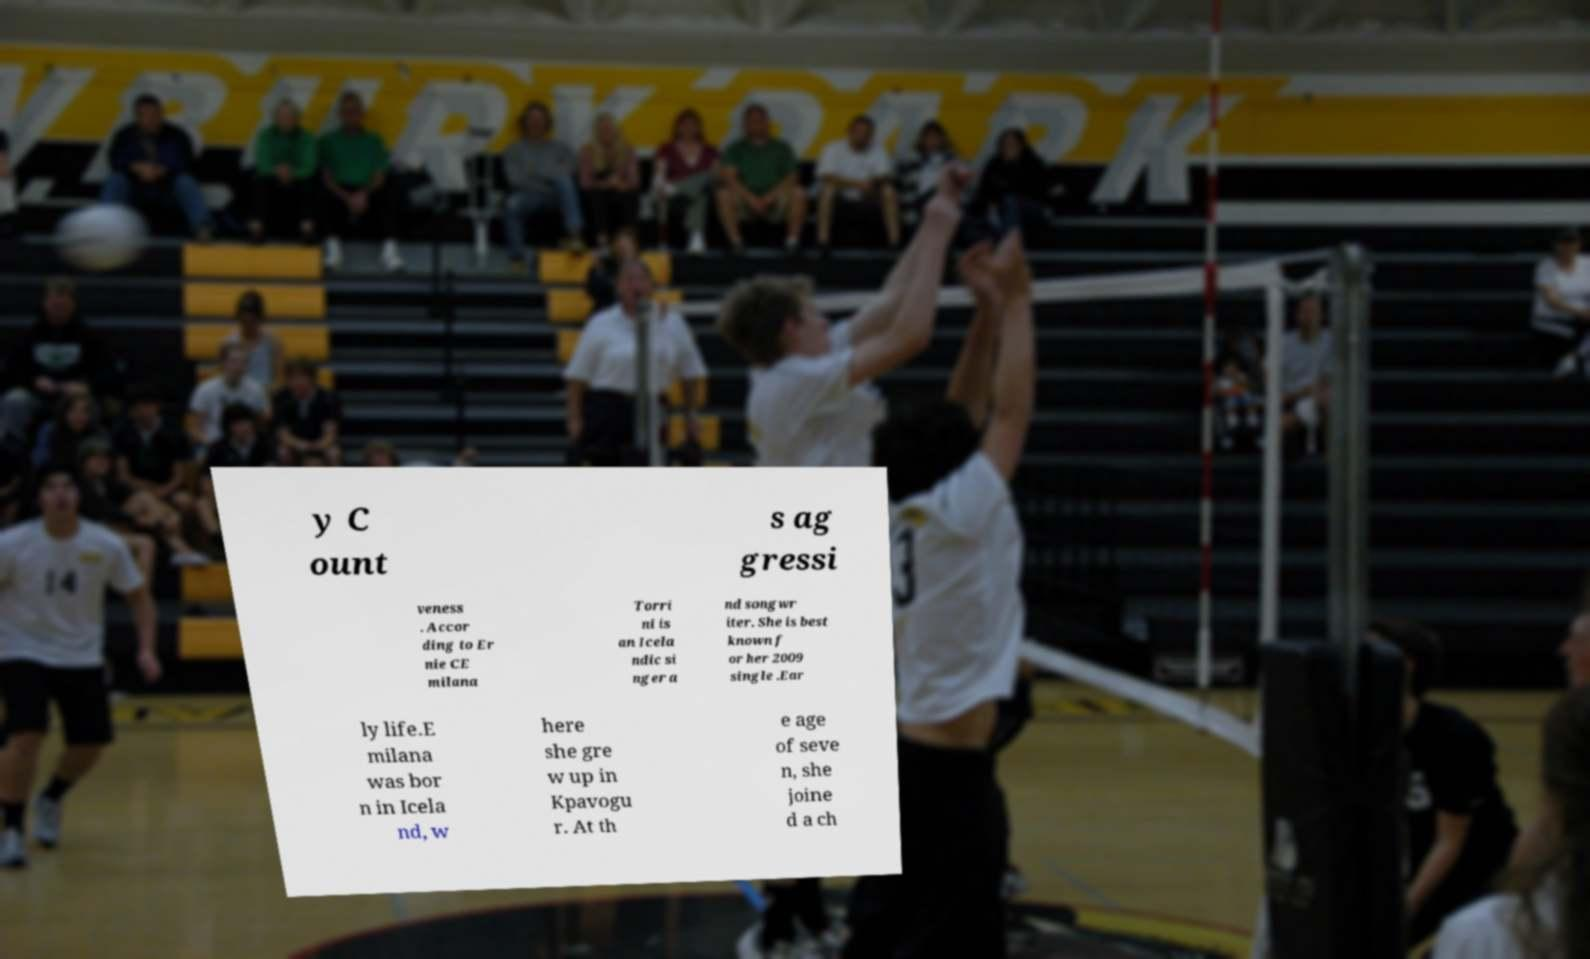Please identify and transcribe the text found in this image. y C ount s ag gressi veness . Accor ding to Er nie CE milana Torri ni is an Icela ndic si nger a nd songwr iter. She is best known f or her 2009 single .Ear ly life.E milana was bor n in Icela nd, w here she gre w up in Kpavogu r. At th e age of seve n, she joine d a ch 